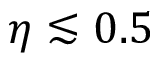<formula> <loc_0><loc_0><loc_500><loc_500>\eta \lesssim 0 . 5</formula> 